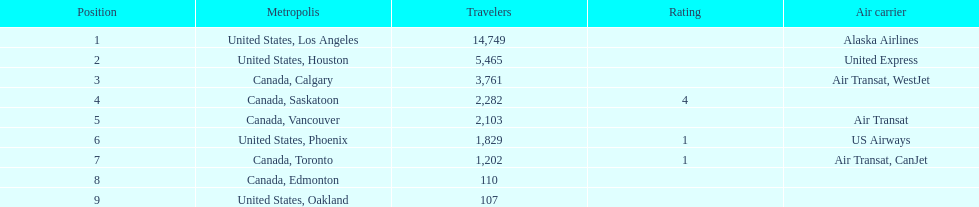Was los angeles or houston the busiest international route at manzanillo international airport in 2013? Los Angeles. 